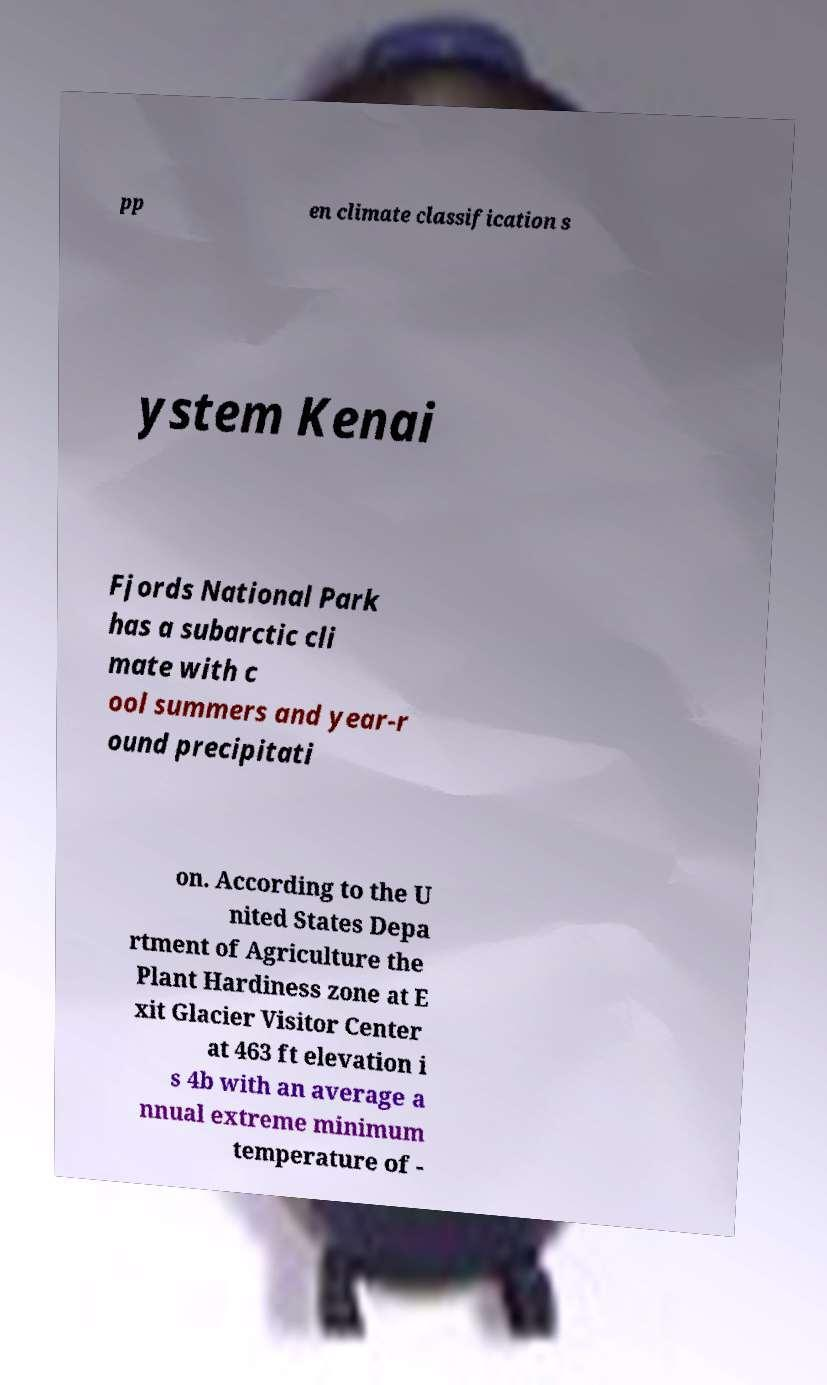Can you read and provide the text displayed in the image?This photo seems to have some interesting text. Can you extract and type it out for me? pp en climate classification s ystem Kenai Fjords National Park has a subarctic cli mate with c ool summers and year-r ound precipitati on. According to the U nited States Depa rtment of Agriculture the Plant Hardiness zone at E xit Glacier Visitor Center at 463 ft elevation i s 4b with an average a nnual extreme minimum temperature of - 